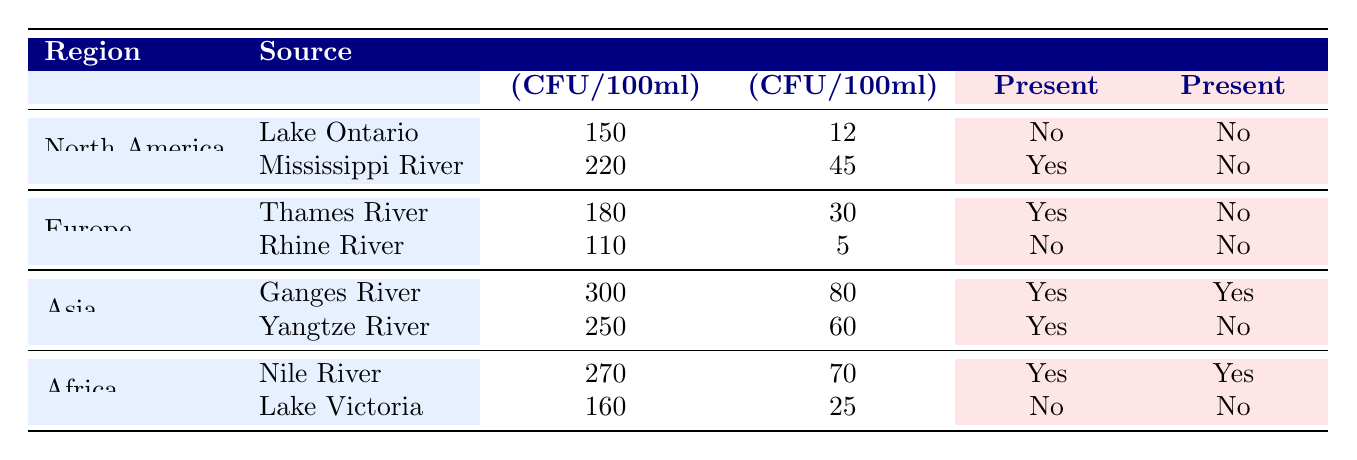What are the total coliform levels in the Ganges River? The table shows that the total coliform level in the Ganges River is 300 CFU per 100ml.
Answer: 300 CFU per 100ml Which water source in North America has the lowest E. coli levels? By examining the E. coli values for Lake Ontario (12 CFU per 100ml) and the Mississippi River (45 CFU per 100ml), Lake Ontario has the lowest E. coli levels.
Answer: Lake Ontario Is Vibrio cholerae present in the Nile River? The table indicates that Vibrio cholerae is present in the Nile River, as it shows "Yes" in the corresponding column.
Answer: Yes What is the average total coliform level of the water sources in Africa? The total coliform levels for the Nile River (270 CFU per 100ml) and Lake Victoria (160 CFU per 100ml) must be averaged: (270 + 160) / 2 = 215 CFU per 100ml.
Answer: 215 CFU per 100ml Which region has the highest level of E. coli contamination? The highest E. coli counts are found in the Ganges River (80 CFU per 100ml), followed by the Yangtze River (60 CFU per 100ml), making Asia the region with the highest E. coli contamination.
Answer: Asia What is the difference in total coliform levels between Lake Victoria and the Ganges River? The total coliform level in Lake Victoria is 160 CFU per 100ml, and in the Ganges River it is 300 CFU per 100ml. The difference is calculated as 300 - 160 = 140 CFU per 100ml.
Answer: 140 CFU per 100ml In which source is Salmonella present and Vibrio cholerae absent? By reviewing the Salmonella and Vibrio cholerae columns, we see that Salmonella is present in the Mississippi River and Thames River while Vibrio cholerae is absent in both.
Answer: Thames River How many water sources in Asia have detected Salmonella? Looking at the sources in Asia, both the Ganges River and Yangtze River have Salmonella present, indicating that there are two water sources with detected Salmonella.
Answer: 2 